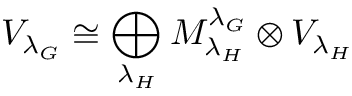<formula> <loc_0><loc_0><loc_500><loc_500>V _ { { \lambda _ { G } } } \cong \bigoplus _ { { \lambda _ { H } } } M _ { \lambda _ { H } } ^ { \lambda _ { G } } \otimes V _ { { \lambda _ { H } } }</formula> 